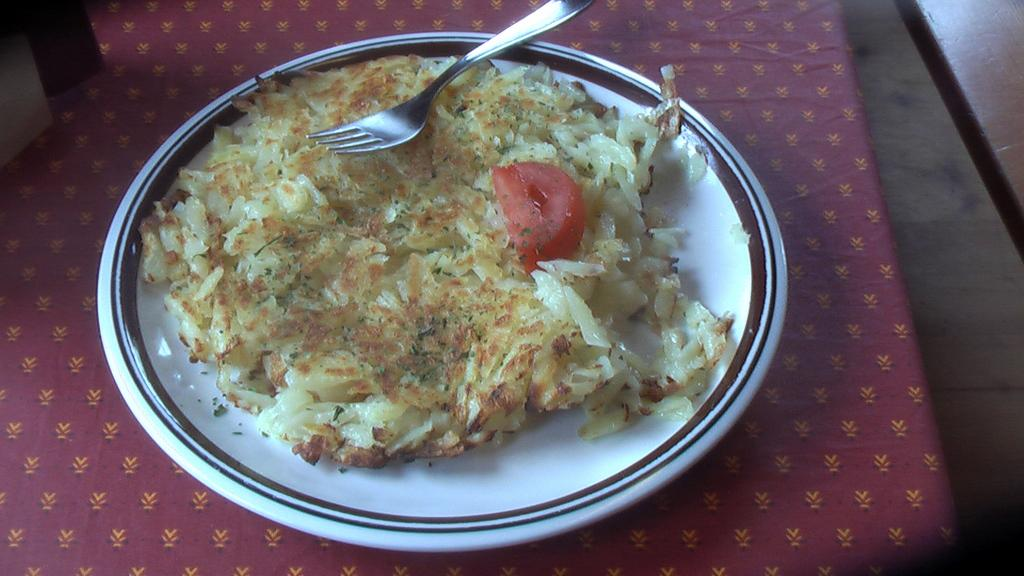What is on the plate in the image? There is a food item on a plate in the image. What utensil is placed on top of the food item? There is a fork placed on top of the food item. Where is the plate located? The plate is on top of a table. What time does the clock on the table show in the image? There is no clock present in the image, so it is not possible to determine the time. 